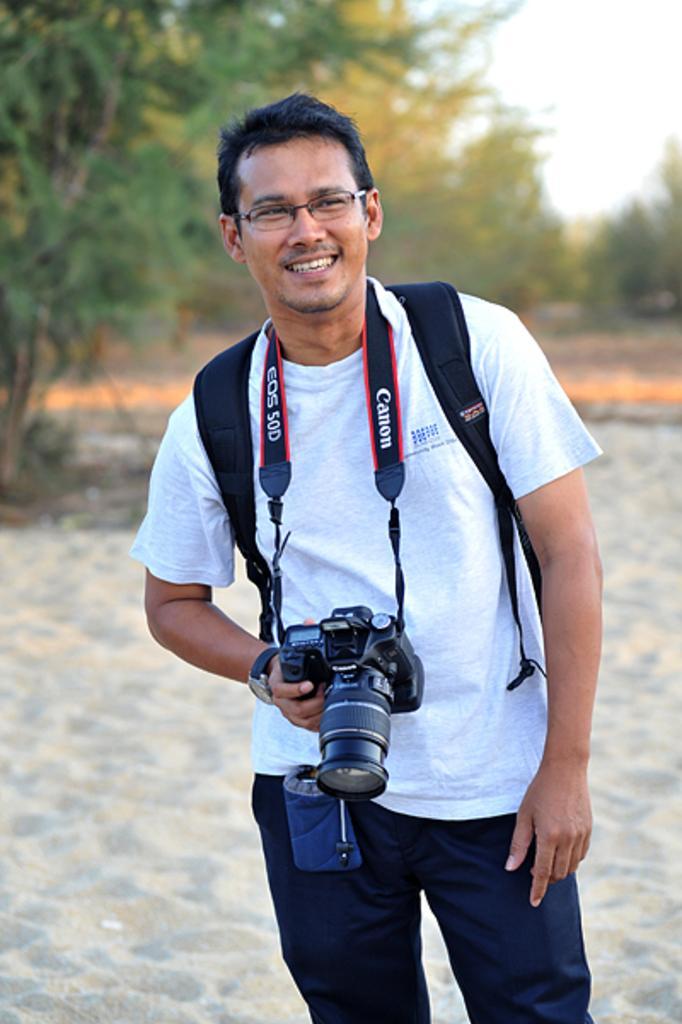Describe this image in one or two sentences. In this image i can see a person is standing and his smiling. And he's wearing a camera on his neck,wearing a watch. back side of him there is a sky,there are some trees visible. 